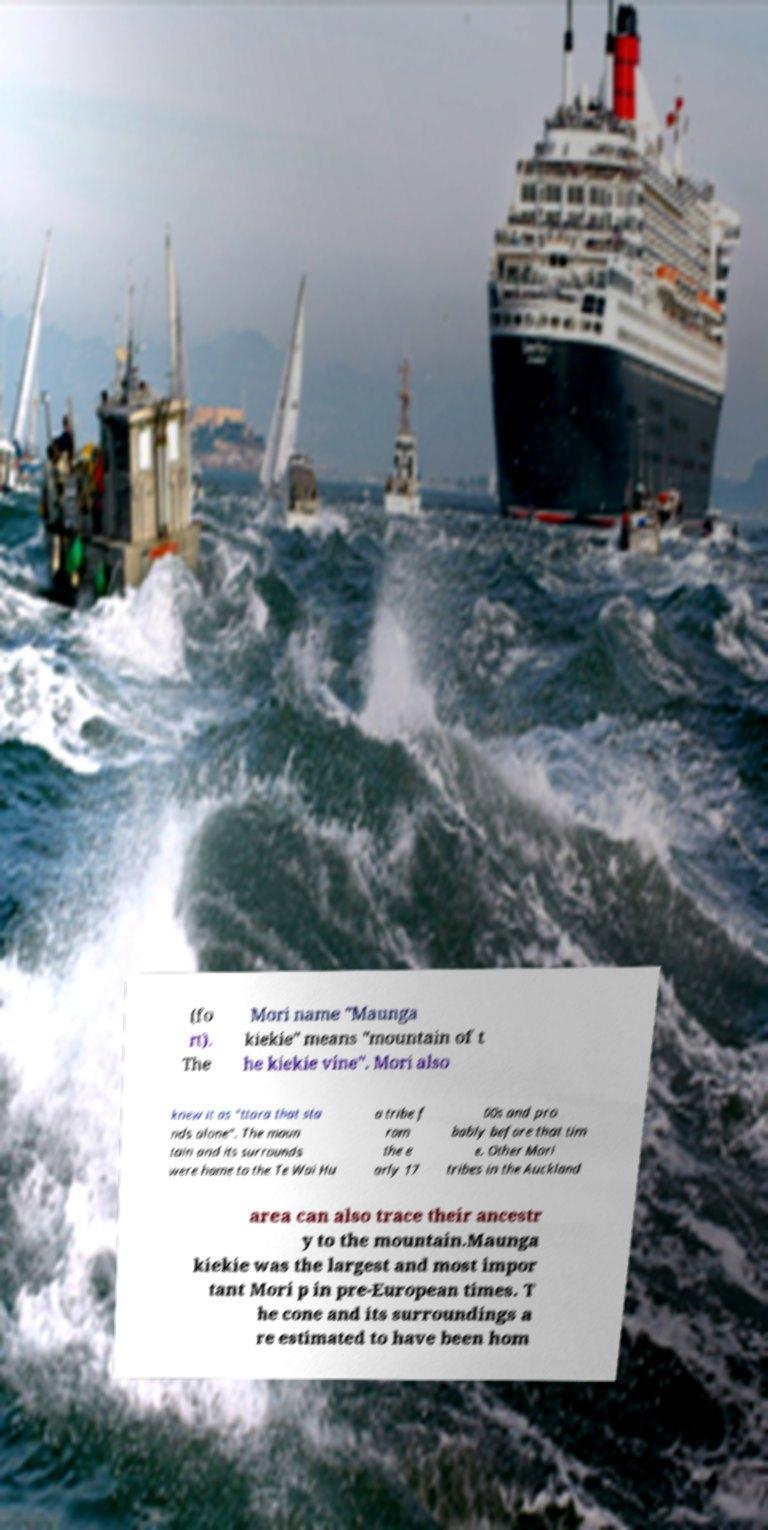There's text embedded in this image that I need extracted. Can you transcribe it verbatim? (fo rt). The Mori name "Maunga kiekie" means "mountain of t he kiekie vine". Mori also knew it as "ttara that sta nds alone". The moun tain and its surrounds were home to the Te Wai Hu a tribe f rom the e arly 17 00s and pro bably before that tim e. Other Mori tribes in the Auckland area can also trace their ancestr y to the mountain.Maunga kiekie was the largest and most impor tant Mori p in pre-European times. T he cone and its surroundings a re estimated to have been hom 